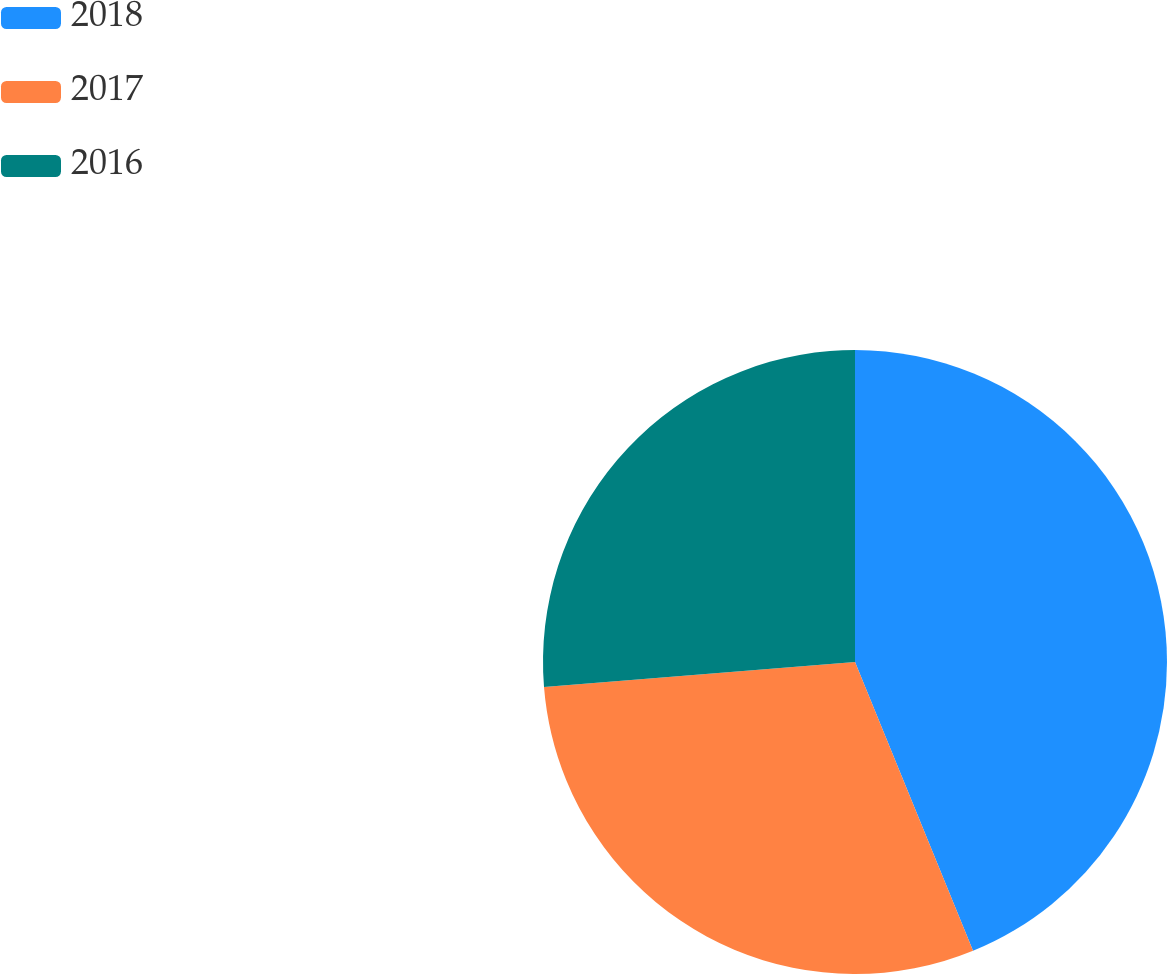<chart> <loc_0><loc_0><loc_500><loc_500><pie_chart><fcel>2018<fcel>2017<fcel>2016<nl><fcel>43.83%<fcel>29.9%<fcel>26.28%<nl></chart> 